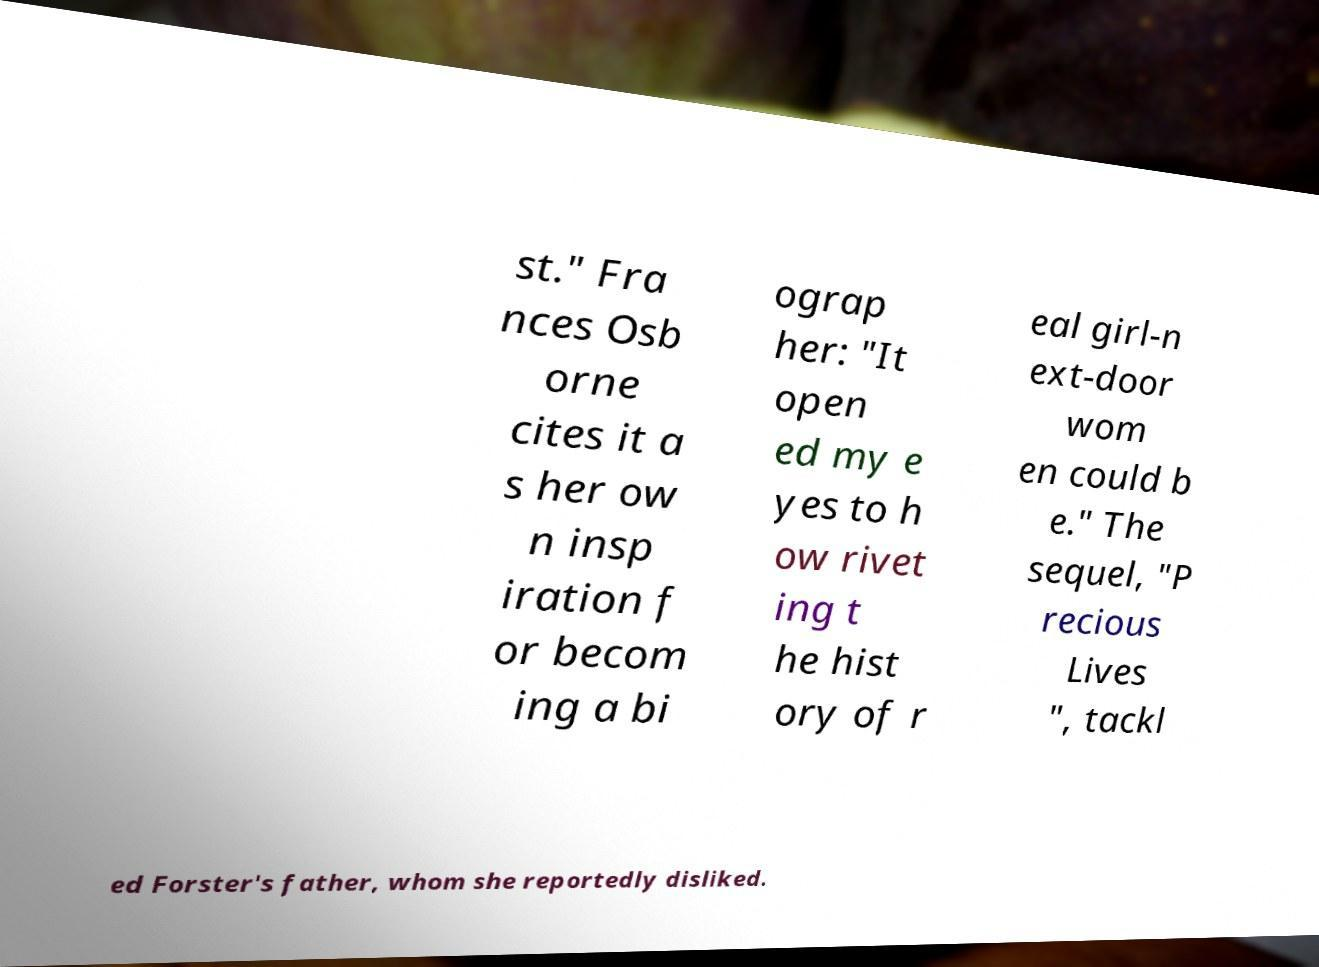Please identify and transcribe the text found in this image. st." Fra nces Osb orne cites it a s her ow n insp iration f or becom ing a bi ograp her: "It open ed my e yes to h ow rivet ing t he hist ory of r eal girl-n ext-door wom en could b e." The sequel, "P recious Lives ", tackl ed Forster's father, whom she reportedly disliked. 